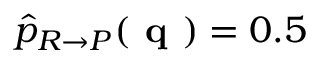Convert formula to latex. <formula><loc_0><loc_0><loc_500><loc_500>\widehat { p } _ { R \rightarrow P } ( q ) = 0 . 5</formula> 